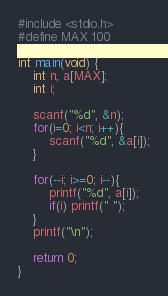Convert code to text. <code><loc_0><loc_0><loc_500><loc_500><_C_>#include <stdio.h>
#define MAX 100

int main(void) {
    int n, a[MAX];
    int i;

    scanf("%d", &n);
    for(i=0; i<n; i++){
        scanf("%d", &a[i]);
    }
    
    for(--i; i>=0; i--){
        printf("%d", a[i]);
        if(i) printf(" ");
    }
    printf("\n");

    return 0;
}</code> 